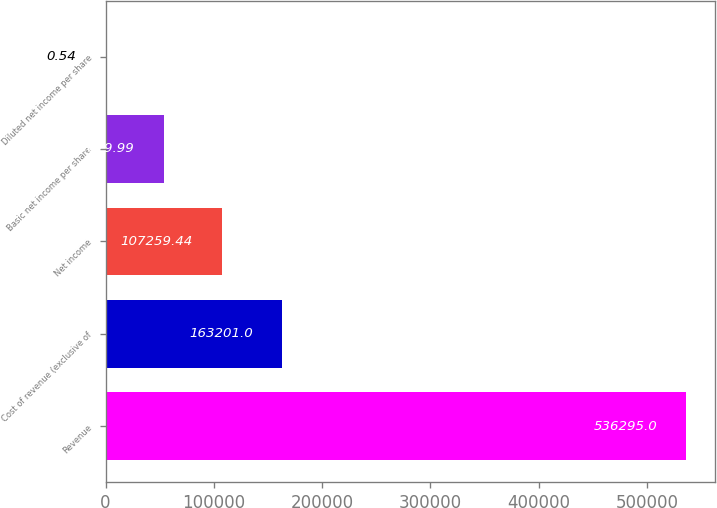Convert chart. <chart><loc_0><loc_0><loc_500><loc_500><bar_chart><fcel>Revenue<fcel>Cost of revenue (exclusive of<fcel>Net income<fcel>Basic net income per share<fcel>Diluted net income per share<nl><fcel>536295<fcel>163201<fcel>107259<fcel>53630<fcel>0.54<nl></chart> 